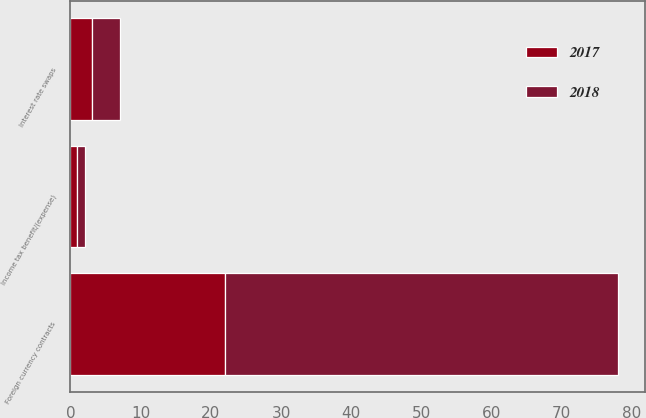Convert chart to OTSL. <chart><loc_0><loc_0><loc_500><loc_500><stacked_bar_chart><ecel><fcel>Interest rate swaps<fcel>Foreign currency contracts<fcel>Income tax benefit/(expense)<nl><fcel>2017<fcel>3<fcel>22<fcel>1<nl><fcel>2018<fcel>4<fcel>56<fcel>1<nl></chart> 